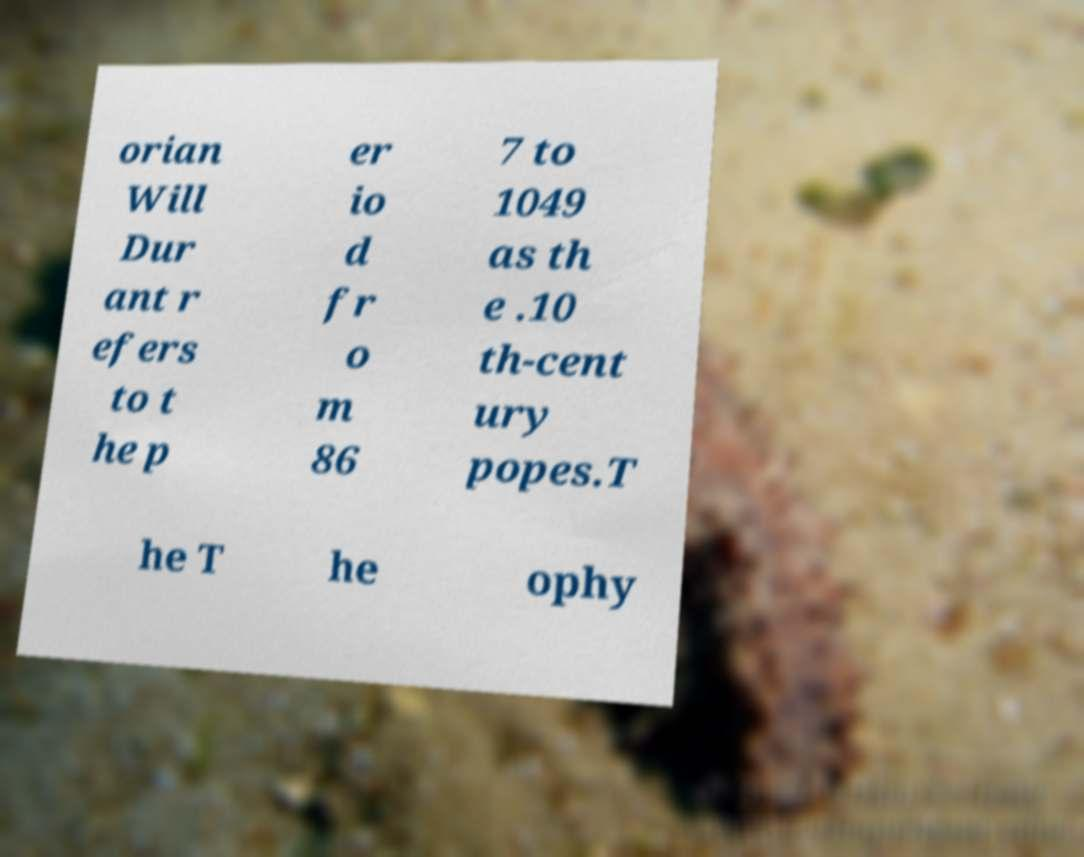I need the written content from this picture converted into text. Can you do that? orian Will Dur ant r efers to t he p er io d fr o m 86 7 to 1049 as th e .10 th-cent ury popes.T he T he ophy 